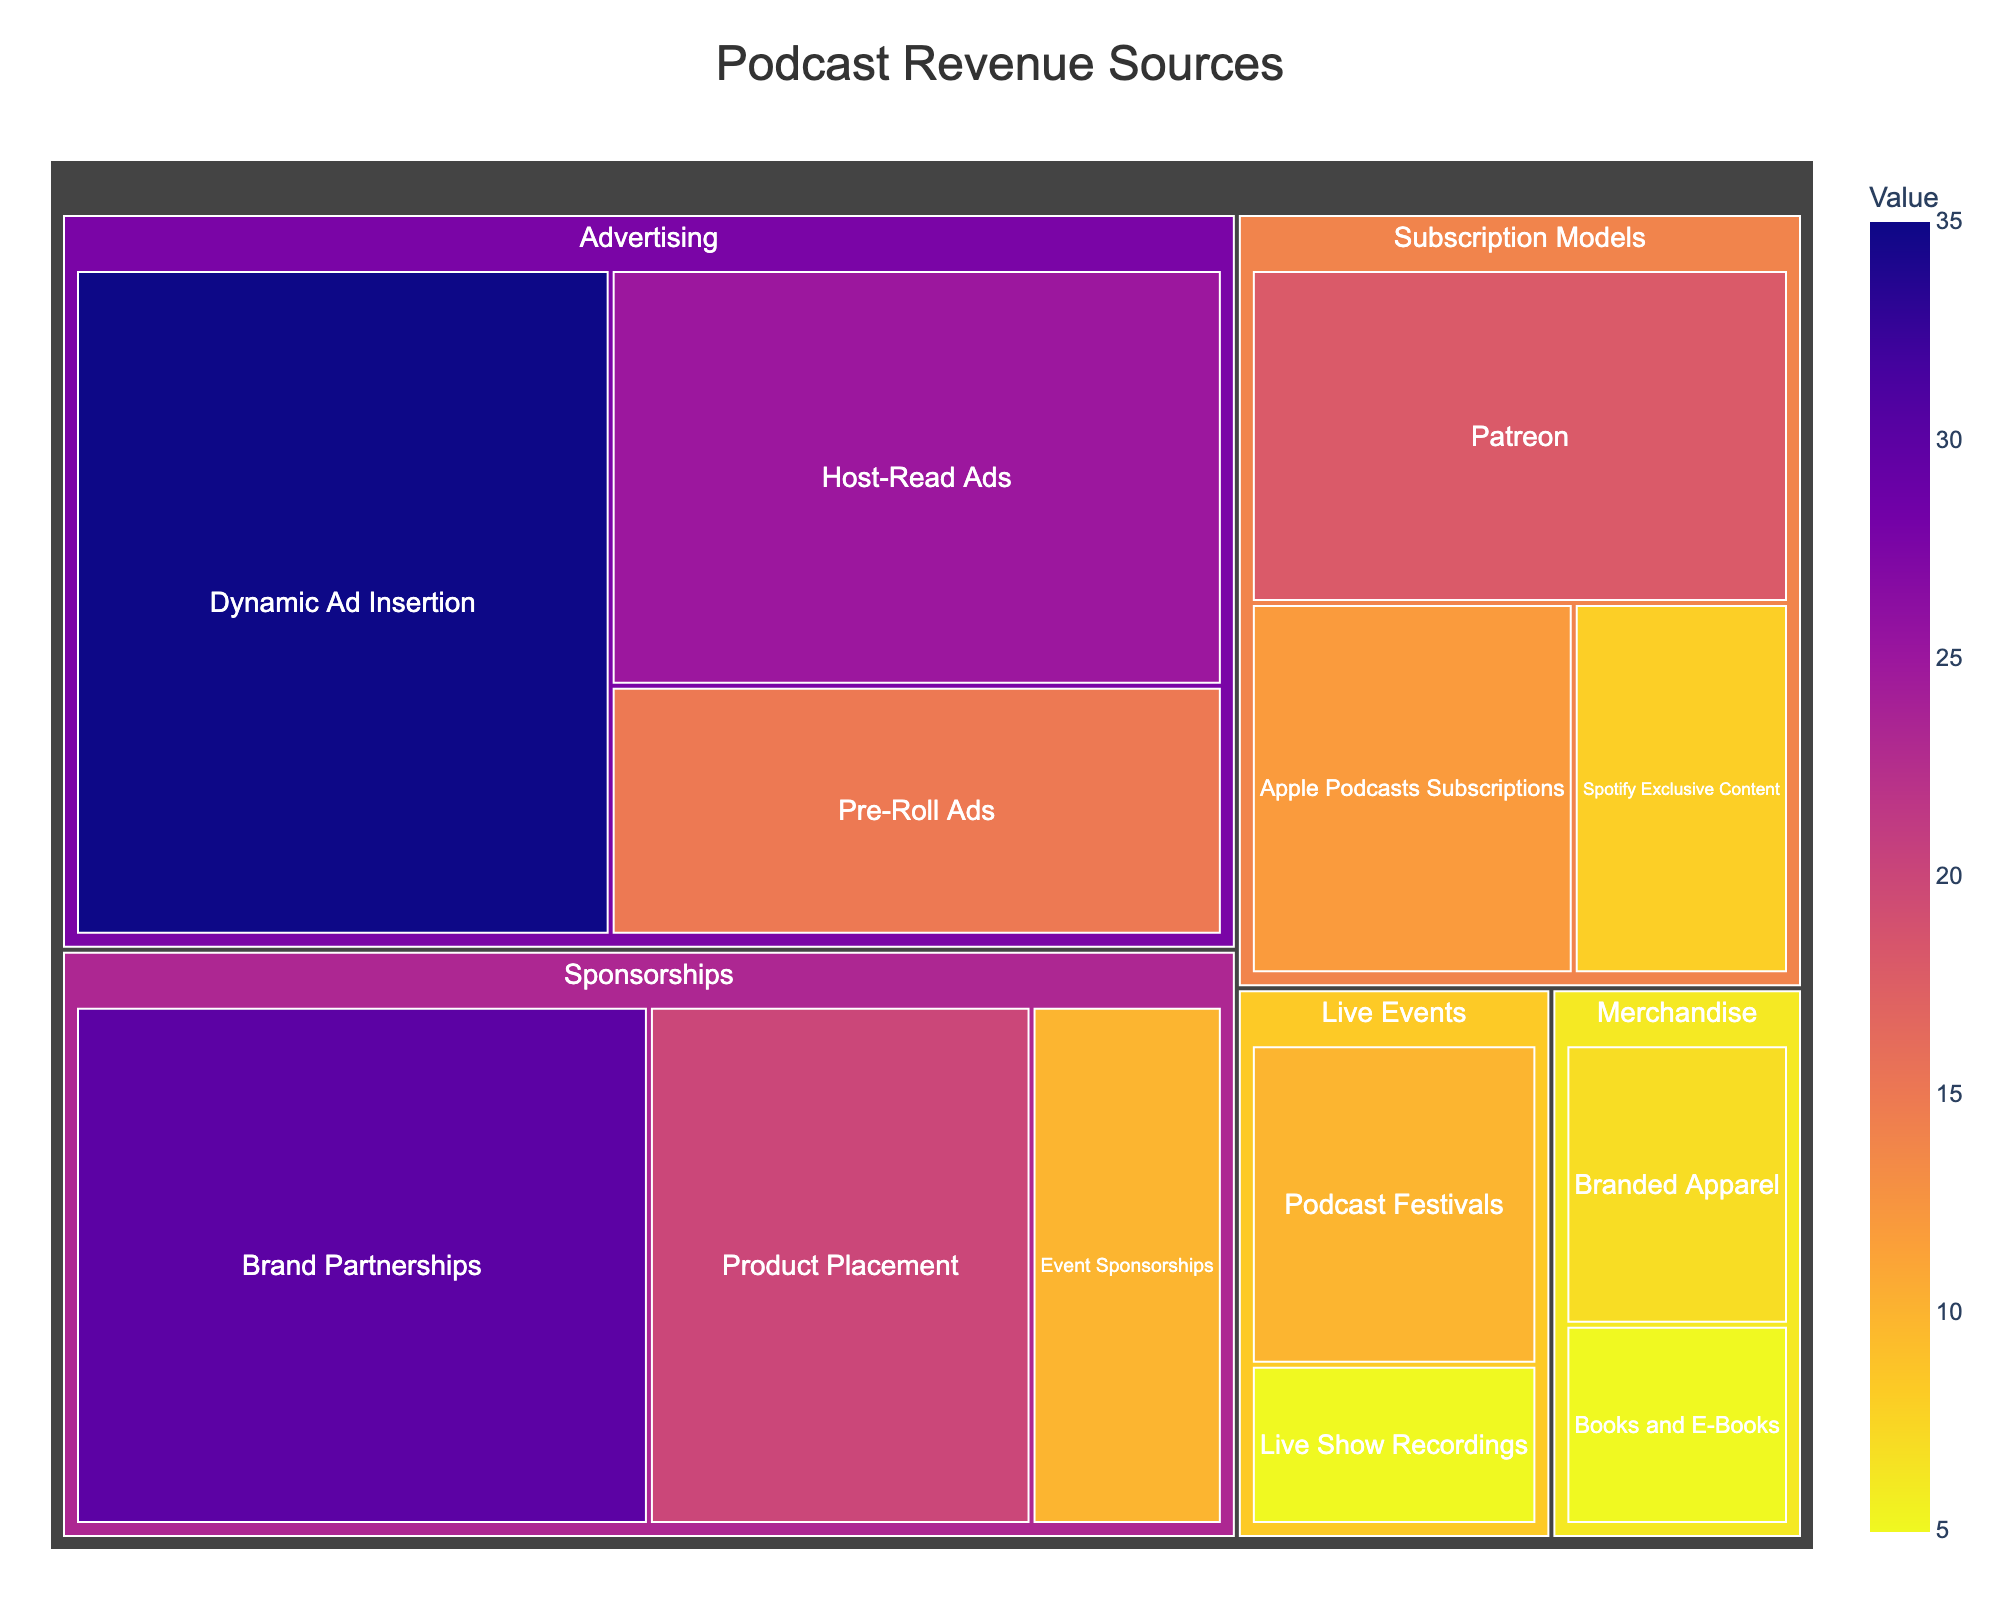What is the title of the Treemap? The title of the Treemap can be found at the top of the chart. It provides a quick summary of what the chart is about.
Answer: Podcast Revenue Sources Which subcategory within Advertising has the highest value? Look for the subcategories under Advertising and compare their values. The subcategory within Advertising with the highest value is Dynamic Ad Insertion with a value of 35.
Answer: Dynamic Ad Insertion How much revenue in total comes from Sponsorships? To find the total revenue from Sponsorships, add the values of all subcategories under Sponsorships: Brand Partnerships (30), Product Placement (20), and Event Sponsorships (10). \(30 + 20 + 10 = 60\).
Answer: 60 Is the revenue from Host-Read Ads greater than from Brand Partnerships? Compare the values of Host-Read Ads (25) and Brand Partnerships (30). Since 25 is less than 30, Host-Read Ads bring in less revenue than Brand Partnerships.
Answer: No What is the combined revenue of the Subscription Models category? Add the values for all subcategories under Subscription Models: Patreon (18), Apple Podcasts Subscriptions (12), and Spotify Exclusive Content (8). \(18 + 12 + 8 = 38\).
Answer: 38 Which source contributes the least revenue to Podcasts? Identify the subcategory with the smallest value across all categories. Books and E-Books under Merchandise have the lowest value, which is 5.
Answer: Books and E-Books How does the revenue from Pre-Roll Ads compare to that from Live Show Recordings? Compare the values of Pre-Roll Ads (15) and Live Show Recordings (5). Since 15 is greater than 5, Pre-Roll Ads generate more revenue than Live Show Recordings.
Answer: Pre-Roll Ads generates more Are there more revenue subcategories under Advertising or Sponsorships? Count the number of subcategories under both Advertising (3 subcategories) and Sponsorships (3 subcategories).
Answer: They have an equal number What proportion of total revenue comes from Patreon compared to total revenue from Subscription Models? First, find the proportion of Patreon's revenue (18) to the total Subscription Models revenue (38). The proportion is \( \frac{18}{38} \approx 0.47 \) or 47%.
Answer: 47% 